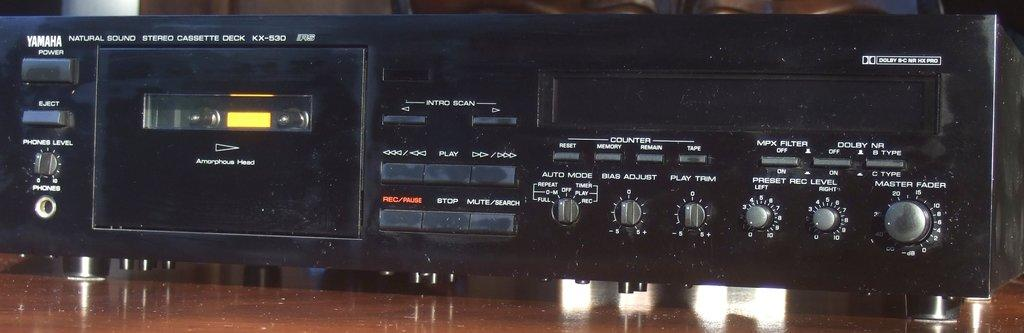<image>
Write a terse but informative summary of the picture. Yamaha is the brand of this cassette deck. 